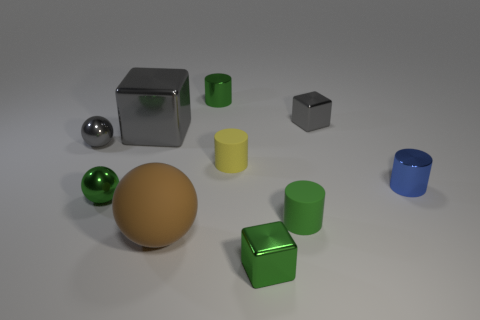Subtract all cylinders. How many objects are left? 6 Add 6 tiny shiny spheres. How many tiny shiny spheres are left? 8 Add 4 gray cubes. How many gray cubes exist? 6 Subtract 1 gray blocks. How many objects are left? 9 Subtract all large things. Subtract all tiny blocks. How many objects are left? 6 